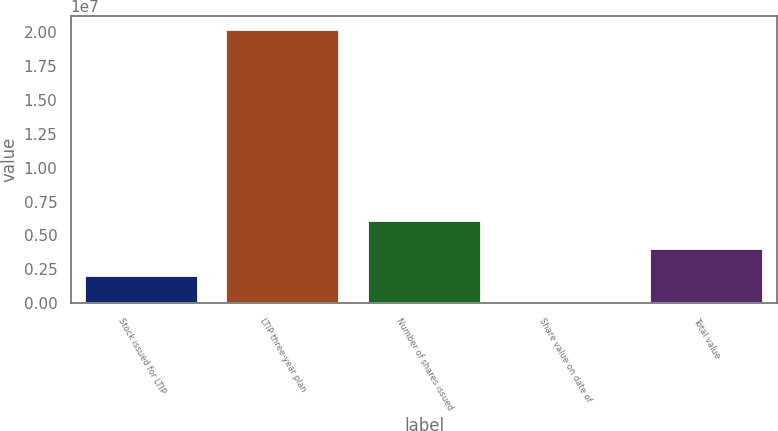Convert chart. <chart><loc_0><loc_0><loc_500><loc_500><bar_chart><fcel>Stock issued for LTIP<fcel>LTIP three-year plan<fcel>Number of shares issued<fcel>Share value on date of<fcel>Total value<nl><fcel>2.01532e+06<fcel>2.01516e+07<fcel>6.04561e+06<fcel>176.39<fcel>4.03046e+06<nl></chart> 